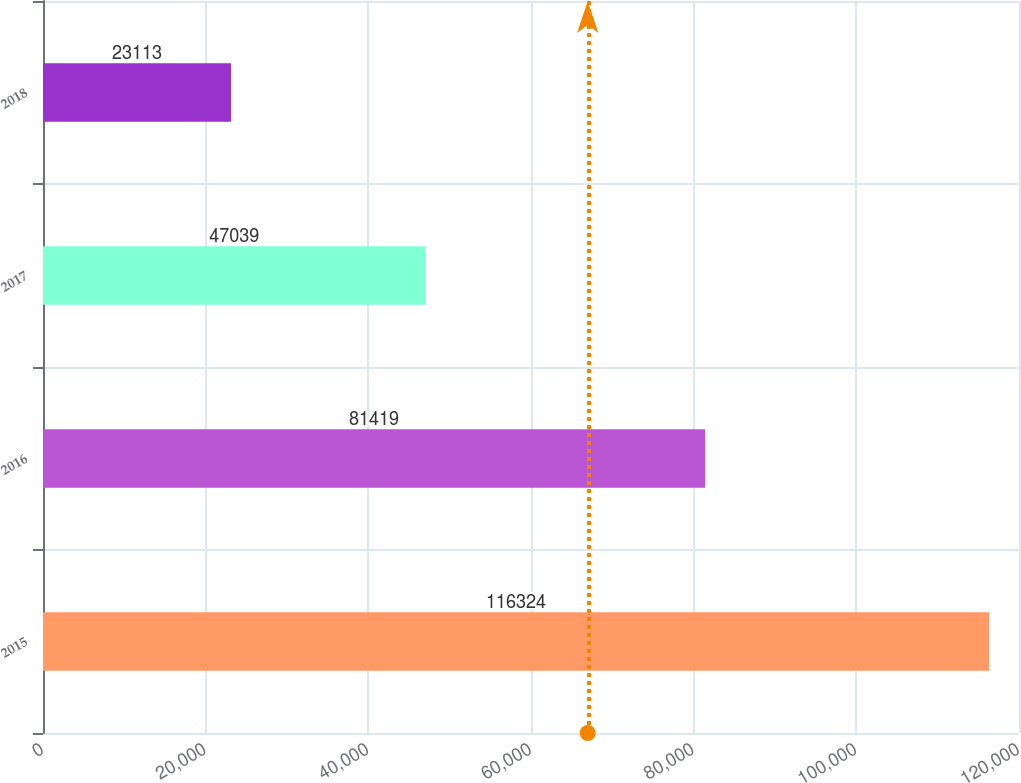<chart> <loc_0><loc_0><loc_500><loc_500><bar_chart><fcel>2015<fcel>2016<fcel>2017<fcel>2018<nl><fcel>116324<fcel>81419<fcel>47039<fcel>23113<nl></chart> 